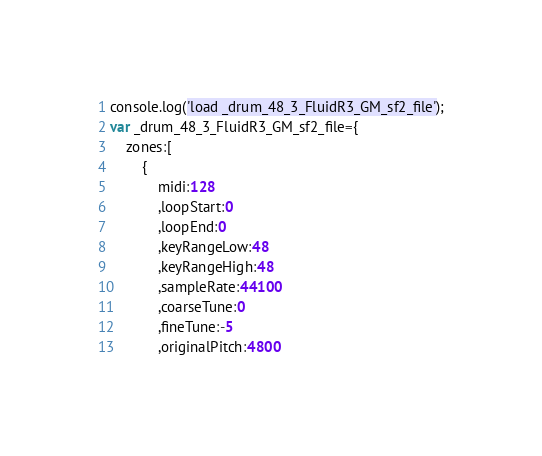Convert code to text. <code><loc_0><loc_0><loc_500><loc_500><_JavaScript_>console.log('load _drum_48_3_FluidR3_GM_sf2_file');
var _drum_48_3_FluidR3_GM_sf2_file={
	zones:[
		{
			midi:128
			,loopStart:0
			,loopEnd:0
			,keyRangeLow:48
			,keyRangeHigh:48
			,sampleRate:44100
			,coarseTune:0
			,fineTune:-5
			,originalPitch:4800</code> 